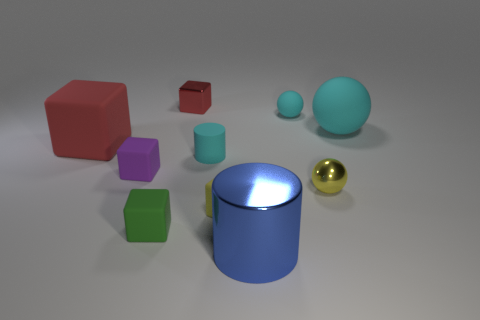Subtract 1 cubes. How many cubes are left? 4 Subtract all green blocks. How many blocks are left? 4 Subtract all large matte blocks. How many blocks are left? 4 Subtract all blue cubes. Subtract all green spheres. How many cubes are left? 5 Subtract all cylinders. How many objects are left? 8 Add 5 cylinders. How many cylinders are left? 7 Add 6 green shiny things. How many green shiny things exist? 6 Subtract 0 gray cylinders. How many objects are left? 10 Subtract all small yellow things. Subtract all red rubber blocks. How many objects are left? 7 